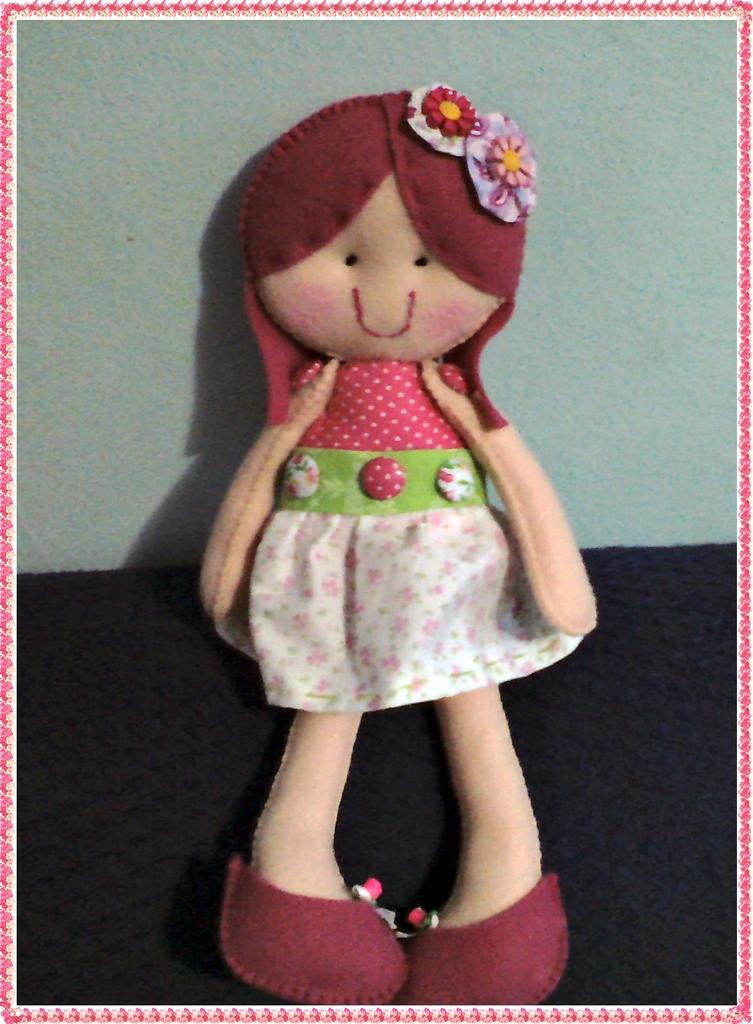What object in the image is designed for play? There is a toy in the image. Where is the toy located? The toy is on a mat. What is visible behind the toy? There is a wall visible behind the toy. What type of humor can be seen in the toy's expression in the image? There is no indication of the toy's expression or any humor in the image. Is the toy being used for a bath in the image? There is no indication of a bath or any water-related activity in the image. 